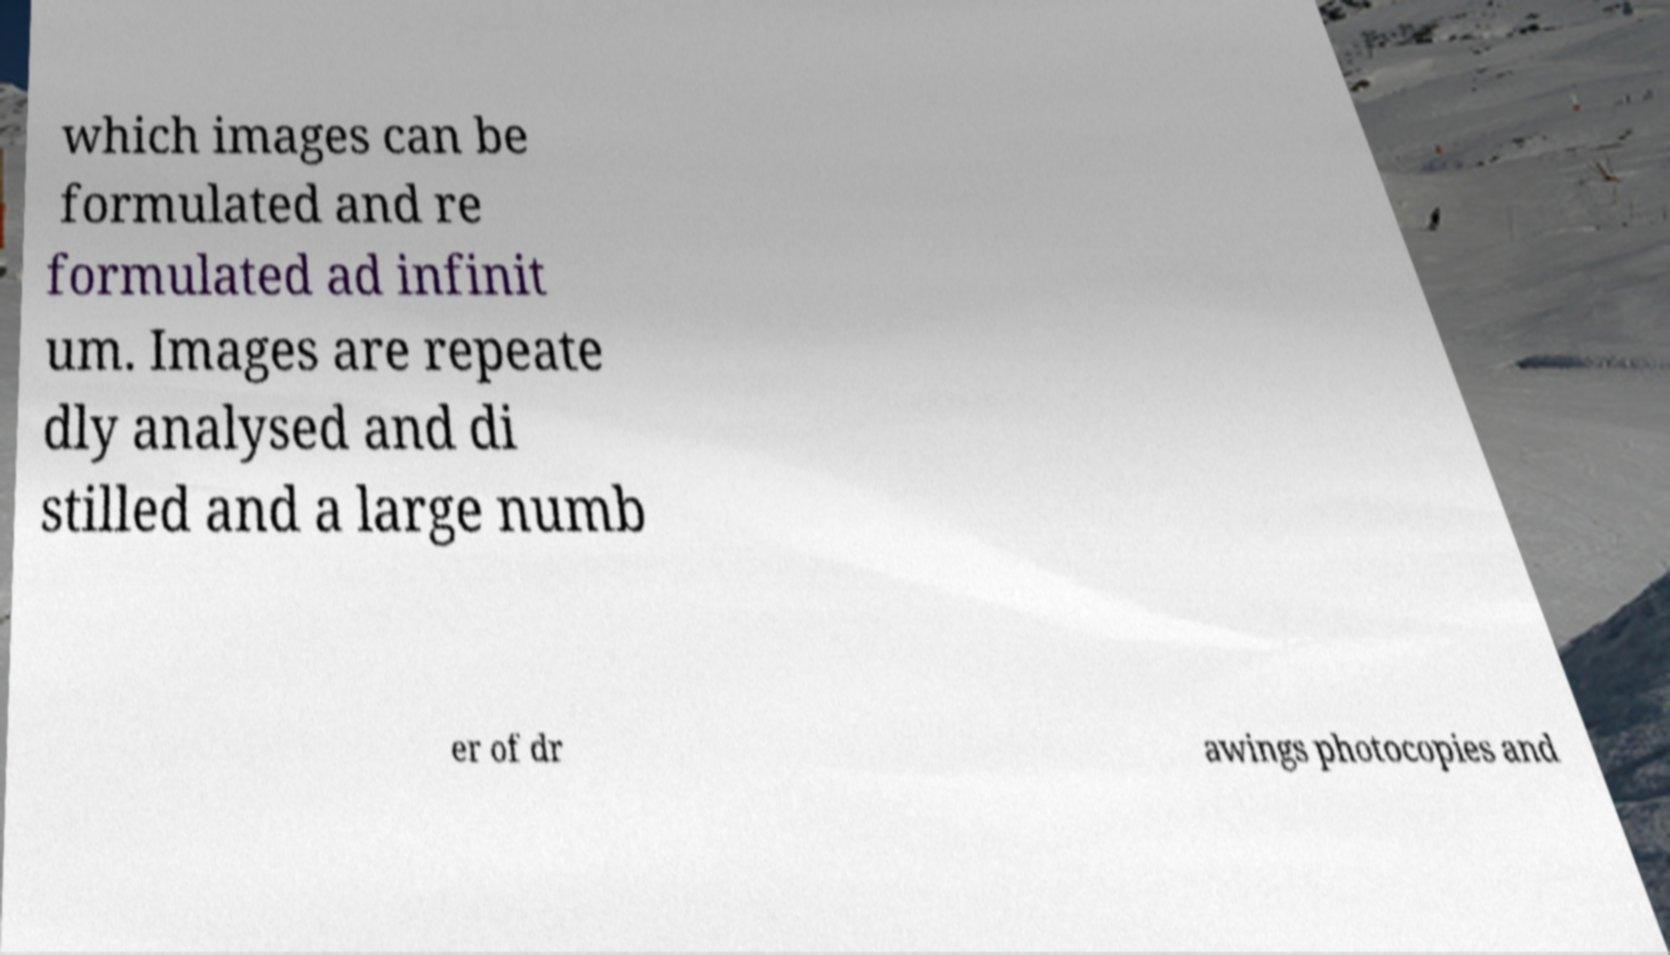What messages or text are displayed in this image? I need them in a readable, typed format. which images can be formulated and re formulated ad infinit um. Images are repeate dly analysed and di stilled and a large numb er of dr awings photocopies and 